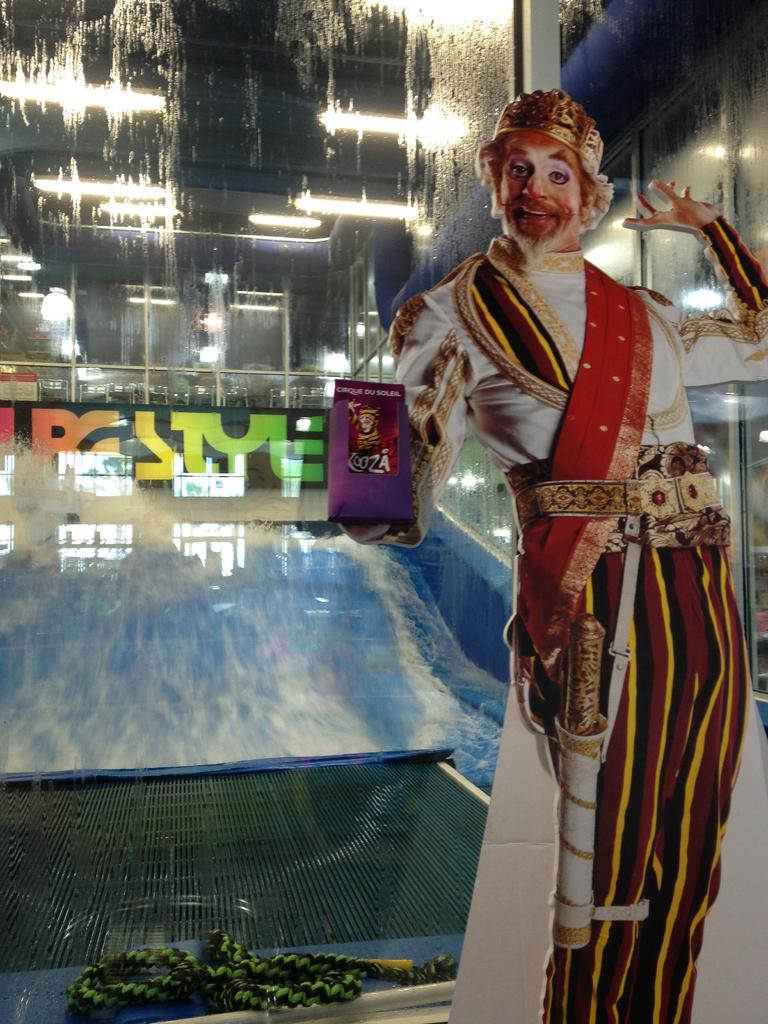What is depicted on the poster in the image? There is a poster of a man in the image. What object can be seen on a platform in the image? There is a rope on a platform in the image. What natural element is visible in the image? There is water visible in the image. What can be seen in the background of the image? There are buildings with lights in the background of the image. Can you tell me who won the argument between the man and his aunt in the image? There is no argument or aunt present in the image; it features a poster of a man, a rope on a platform, water, and buildings with lights in the background. What type of coast can be seen in the image? There is no coast present in the image. 